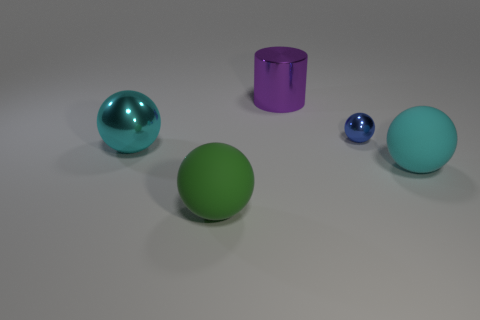How many objects are large cyan metallic spheres or balls?
Keep it short and to the point. 4. The small shiny thing has what shape?
Your answer should be compact. Sphere. There is another cyan object that is the same shape as the large cyan metal object; what size is it?
Provide a short and direct response. Large. How big is the matte thing that is to the right of the rubber ball to the left of the tiny shiny thing?
Make the answer very short. Large. Are there an equal number of blue metallic things on the left side of the big green thing and tiny brown spheres?
Your response must be concise. Yes. What number of other objects are the same color as the tiny object?
Your answer should be compact. 0. Is the number of large cyan metallic spheres that are to the right of the large green rubber sphere less than the number of blue shiny objects?
Provide a short and direct response. Yes. Are there any purple metallic things that have the same size as the cyan metal object?
Offer a very short reply. Yes. There is a large metal ball; is its color the same as the sphere behind the big metallic sphere?
Make the answer very short. No. There is a large rubber sphere behind the big green thing; what number of large things are in front of it?
Your answer should be very brief. 1. 